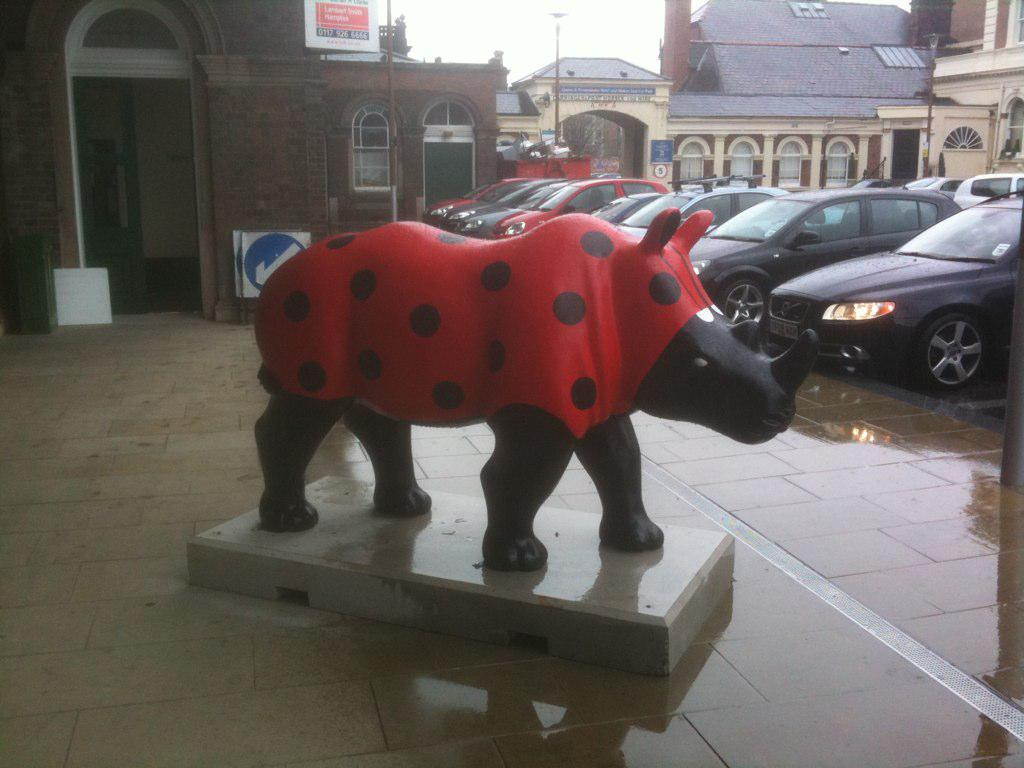What is the main subject in the middle of the image? There is a statue of a bull in the middle of the image. What can be seen in the background of the image? There are cars, buildings, poles, and sign boards in the background of the image. How many mice are climbing on the statue of the bull in the image? There are no mice present in the image; it only features a statue of a bull. Can you describe the kick of the bull in the image? The image does not depict a bull kicking; it is a statue of a bull standing still. 